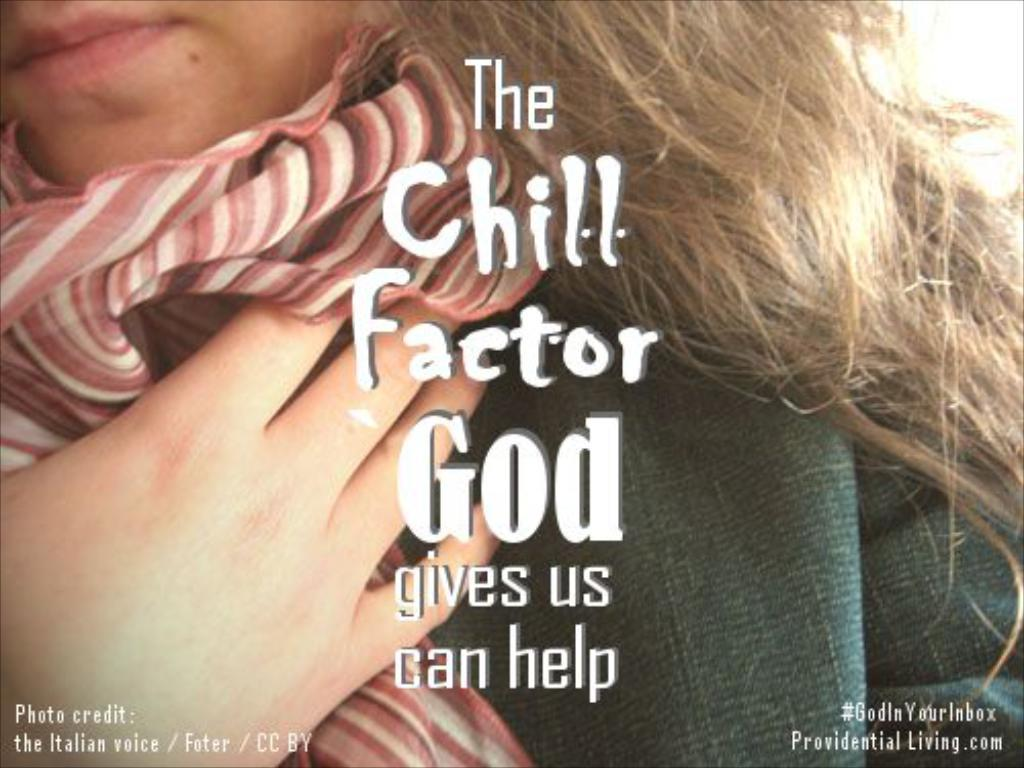Who is present in the image? There is a woman in the image. What is the woman wearing around her neck? The woman is wearing a scarf. What can be seen on the wall in the image? There is a poster in the image. What is written on the poster? There is matter written on the poster. What type of patch can be seen on the woman's clothing in the image? There is no patch visible on the woman's clothing in the image. 